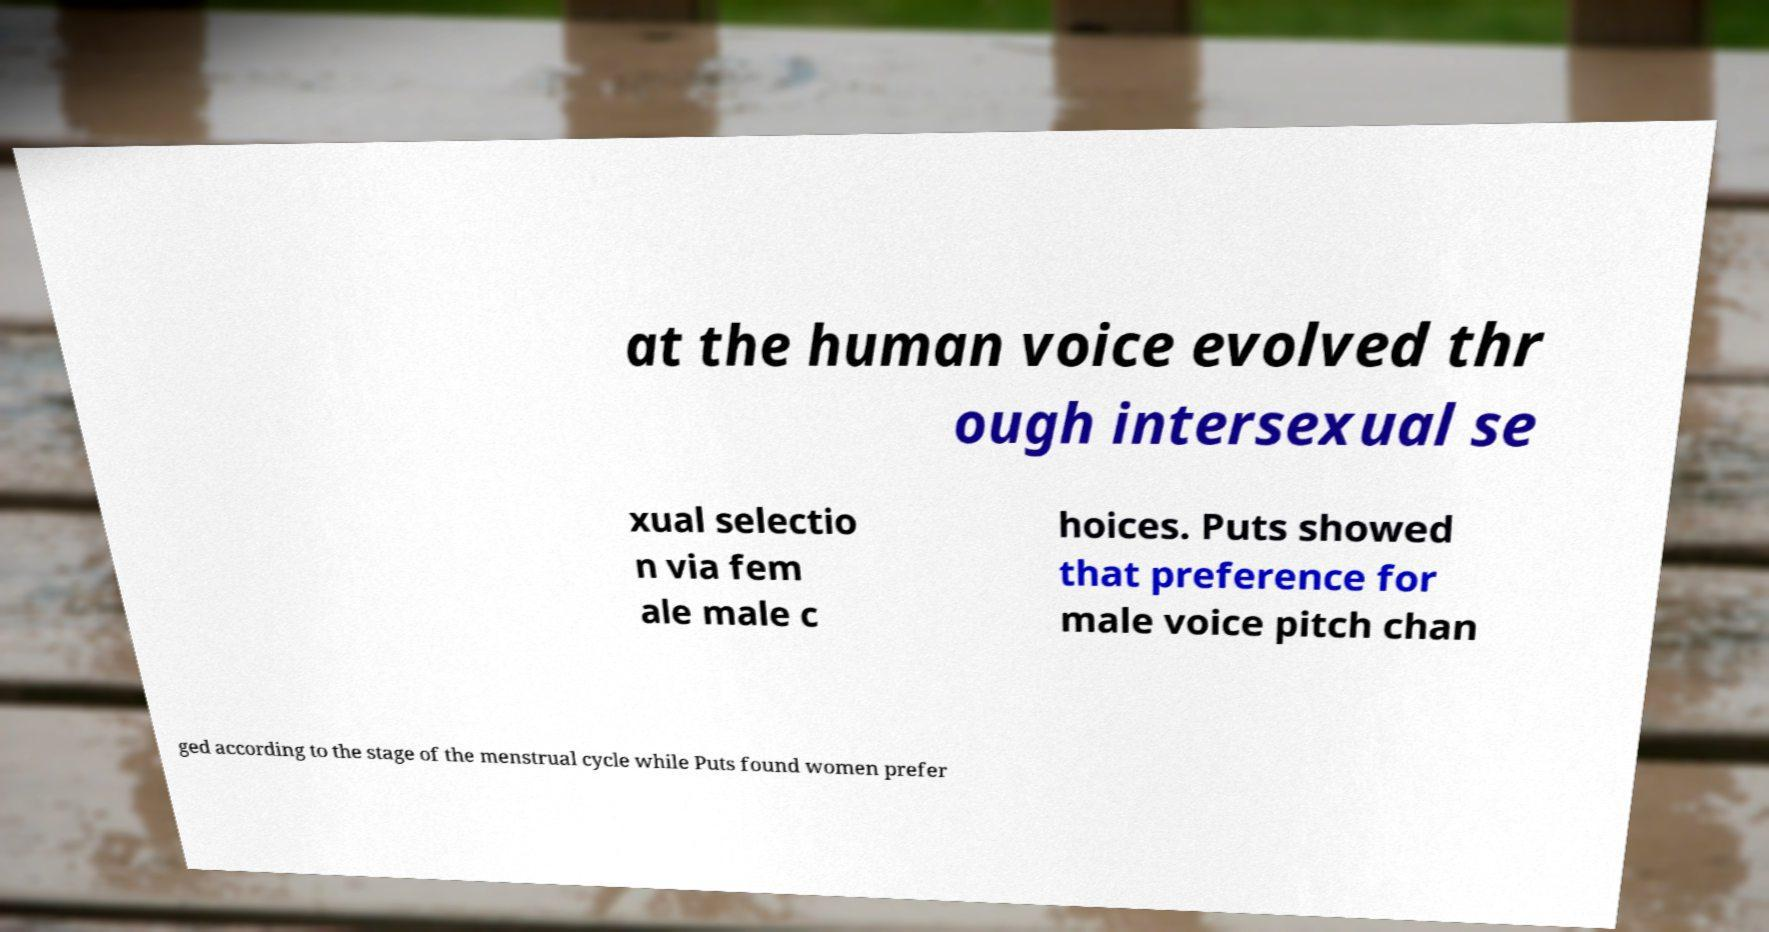Can you accurately transcribe the text from the provided image for me? at the human voice evolved thr ough intersexual se xual selectio n via fem ale male c hoices. Puts showed that preference for male voice pitch chan ged according to the stage of the menstrual cycle while Puts found women prefer 